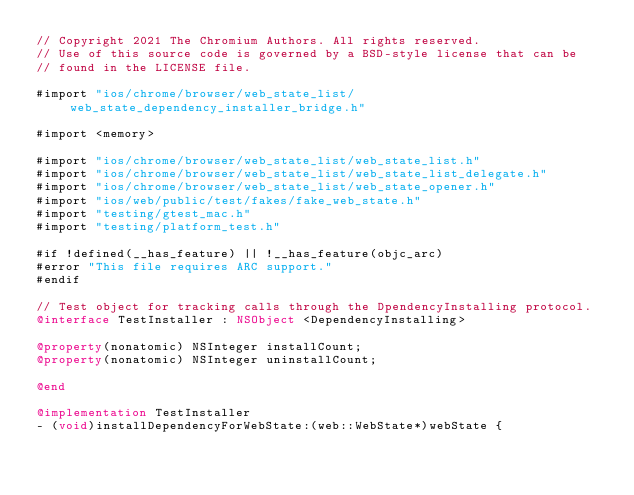<code> <loc_0><loc_0><loc_500><loc_500><_ObjectiveC_>// Copyright 2021 The Chromium Authors. All rights reserved.
// Use of this source code is governed by a BSD-style license that can be
// found in the LICENSE file.

#import "ios/chrome/browser/web_state_list/web_state_dependency_installer_bridge.h"

#import <memory>

#import "ios/chrome/browser/web_state_list/web_state_list.h"
#import "ios/chrome/browser/web_state_list/web_state_list_delegate.h"
#import "ios/chrome/browser/web_state_list/web_state_opener.h"
#import "ios/web/public/test/fakes/fake_web_state.h"
#import "testing/gtest_mac.h"
#import "testing/platform_test.h"

#if !defined(__has_feature) || !__has_feature(objc_arc)
#error "This file requires ARC support."
#endif

// Test object for tracking calls through the DpendencyInstalling protocol.
@interface TestInstaller : NSObject <DependencyInstalling>

@property(nonatomic) NSInteger installCount;
@property(nonatomic) NSInteger uninstallCount;

@end

@implementation TestInstaller
- (void)installDependencyForWebState:(web::WebState*)webState {</code> 